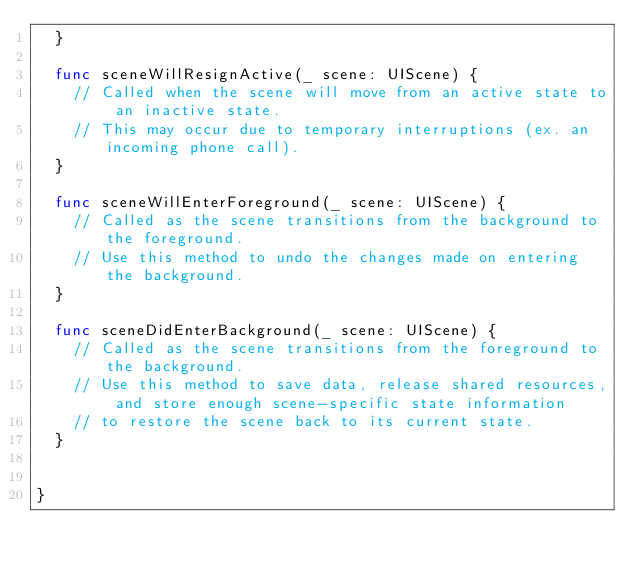<code> <loc_0><loc_0><loc_500><loc_500><_Swift_>  }

  func sceneWillResignActive(_ scene: UIScene) {
    // Called when the scene will move from an active state to an inactive state.
    // This may occur due to temporary interruptions (ex. an incoming phone call).
  }

  func sceneWillEnterForeground(_ scene: UIScene) {
    // Called as the scene transitions from the background to the foreground.
    // Use this method to undo the changes made on entering the background.
  }

  func sceneDidEnterBackground(_ scene: UIScene) {
    // Called as the scene transitions from the foreground to the background.
    // Use this method to save data, release shared resources, and store enough scene-specific state information
    // to restore the scene back to its current state.
  }


}

</code> 